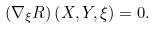<formula> <loc_0><loc_0><loc_500><loc_500>\left ( \nabla _ { \xi } R \right ) \left ( X , Y , \xi \right ) = 0 .</formula> 